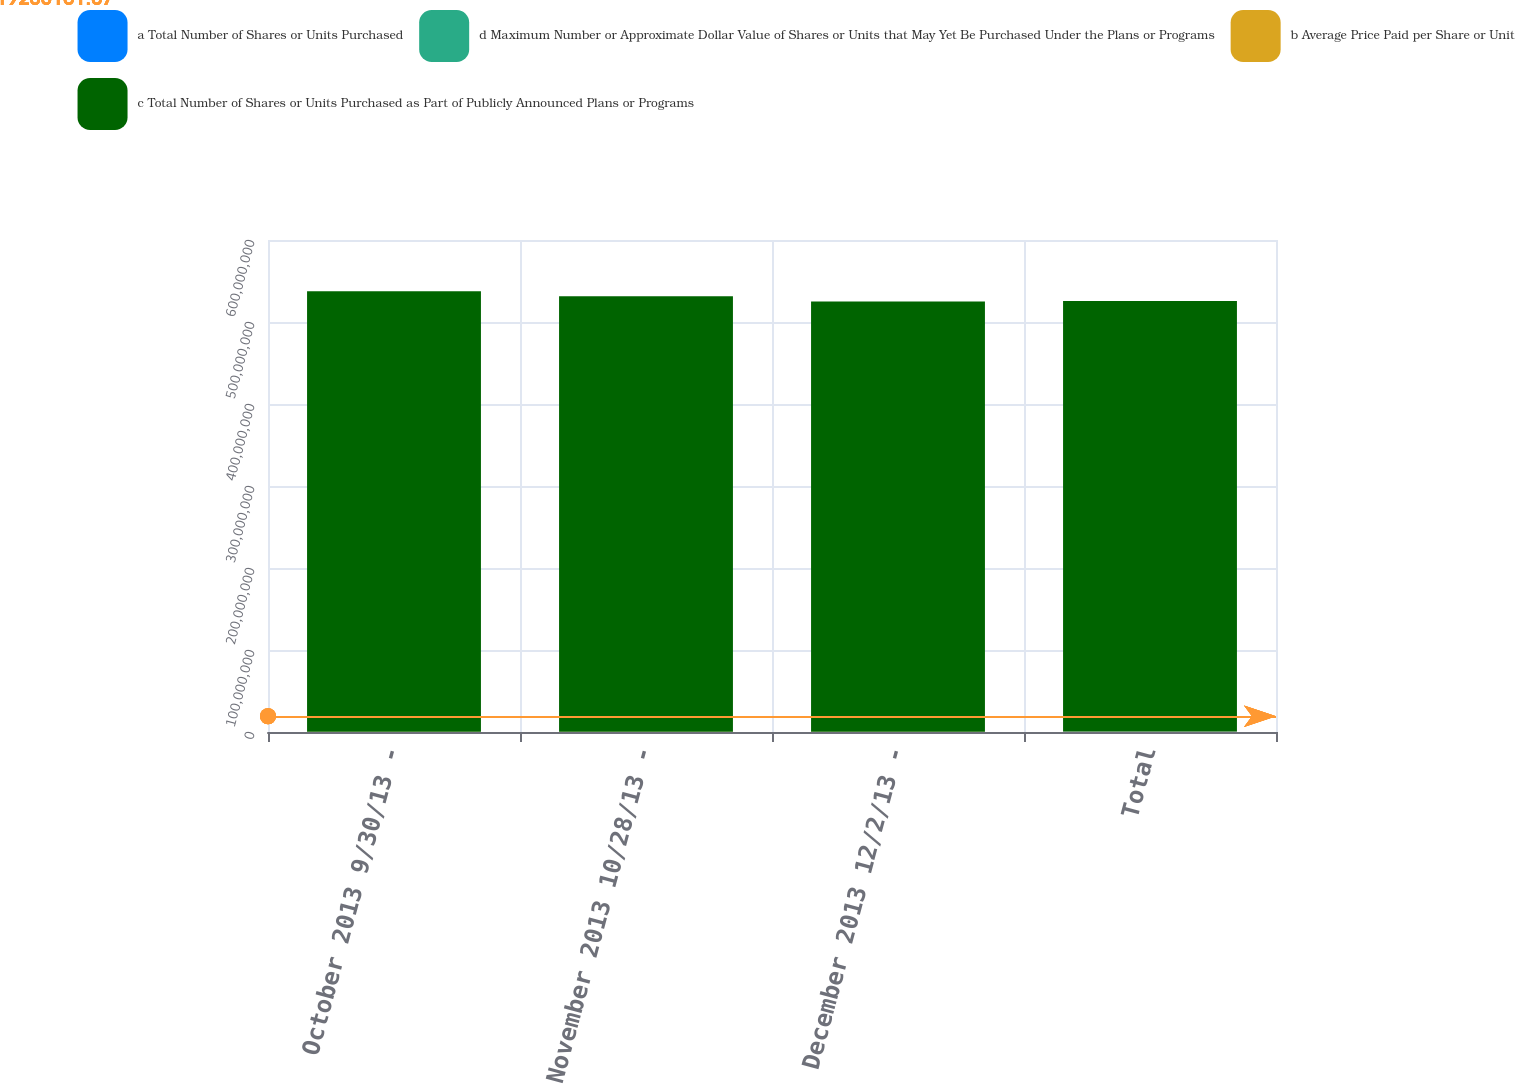Convert chart. <chart><loc_0><loc_0><loc_500><loc_500><stacked_bar_chart><ecel><fcel>October 2013 9/30/13 -<fcel>November 2013 10/28/13 -<fcel>December 2013 12/2/13 -<fcel>Total<nl><fcel>a Total Number of Shares or Units Purchased<fcel>97500<fcel>113000<fcel>123500<fcel>334000<nl><fcel>d Maximum Number or Approximate Dollar Value of Shares or Units that May Yet Be Purchased Under the Plans or Programs<fcel>46.7<fcel>52.34<fcel>52.48<fcel>50.75<nl><fcel>b Average Price Paid per Share or Unit<fcel>97500<fcel>113000<fcel>123500<fcel>334000<nl><fcel>c Total Number of Shares or Units Purchased as Part of Publicly Announced Plans or Programs<fcel>5.37218e+08<fcel>5.31304e+08<fcel>5.24822e+08<fcel>5.24822e+08<nl></chart> 